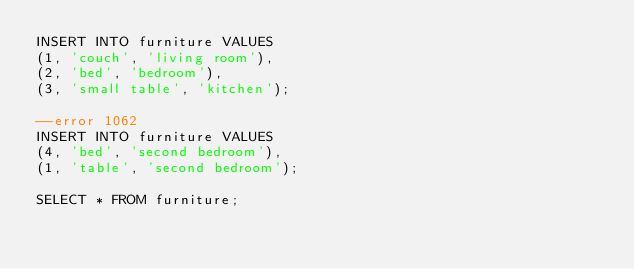Convert code to text. <code><loc_0><loc_0><loc_500><loc_500><_SQL_>INSERT INTO furniture VALUES
(1, 'couch', 'living room'),
(2, 'bed', 'bedroom'),
(3, 'small table', 'kitchen');

--error 1062
INSERT INTO furniture VALUES
(4, 'bed', 'second bedroom'),
(1, 'table', 'second bedroom');

SELECT * FROM furniture;
</code> 